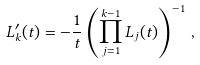<formula> <loc_0><loc_0><loc_500><loc_500>L _ { k } ^ { \prime } ( t ) = - \frac { 1 } { t } \left ( \prod _ { j = 1 } ^ { k - 1 } L _ { j } ( t ) \right ) ^ { - 1 } \, ,</formula> 